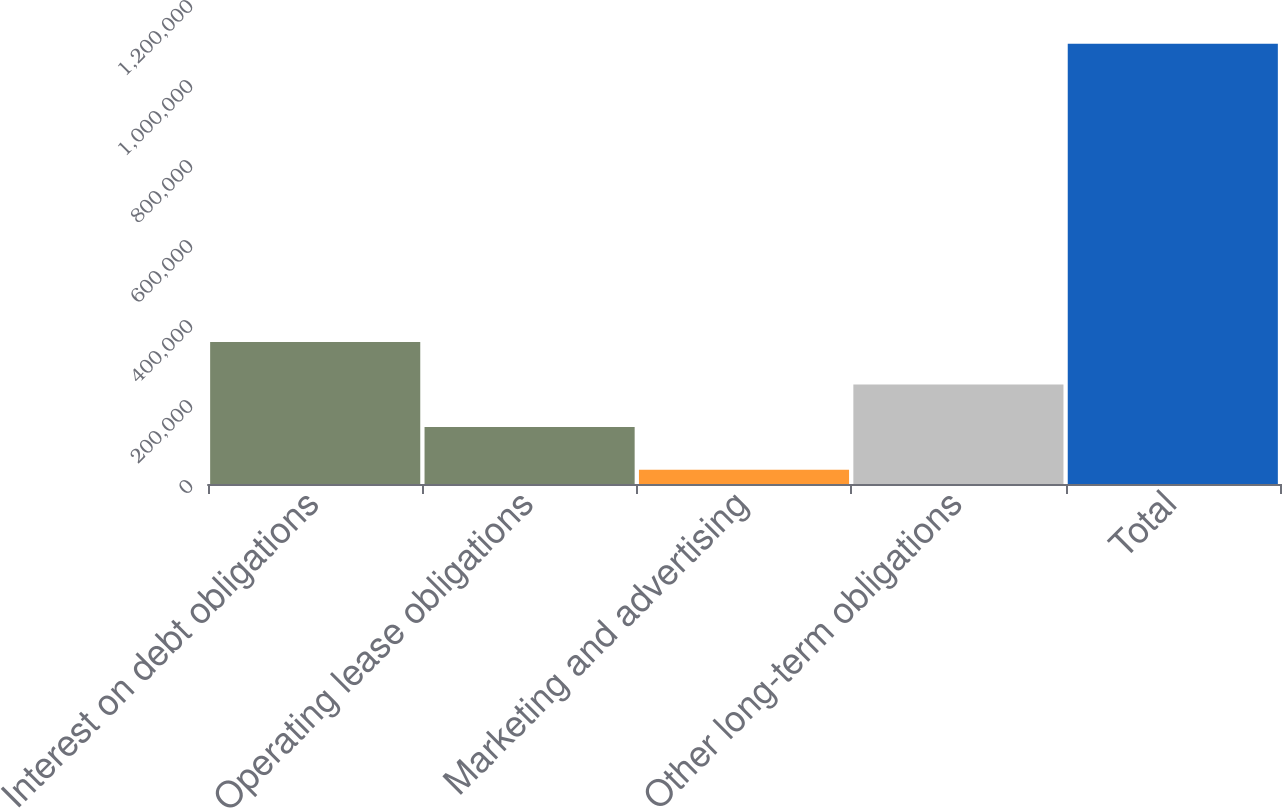<chart> <loc_0><loc_0><loc_500><loc_500><bar_chart><fcel>Interest on debt obligations<fcel>Operating lease obligations<fcel>Marketing and advertising<fcel>Other long-term obligations<fcel>Total<nl><fcel>355262<fcel>142312<fcel>35837<fcel>248787<fcel>1.10059e+06<nl></chart> 